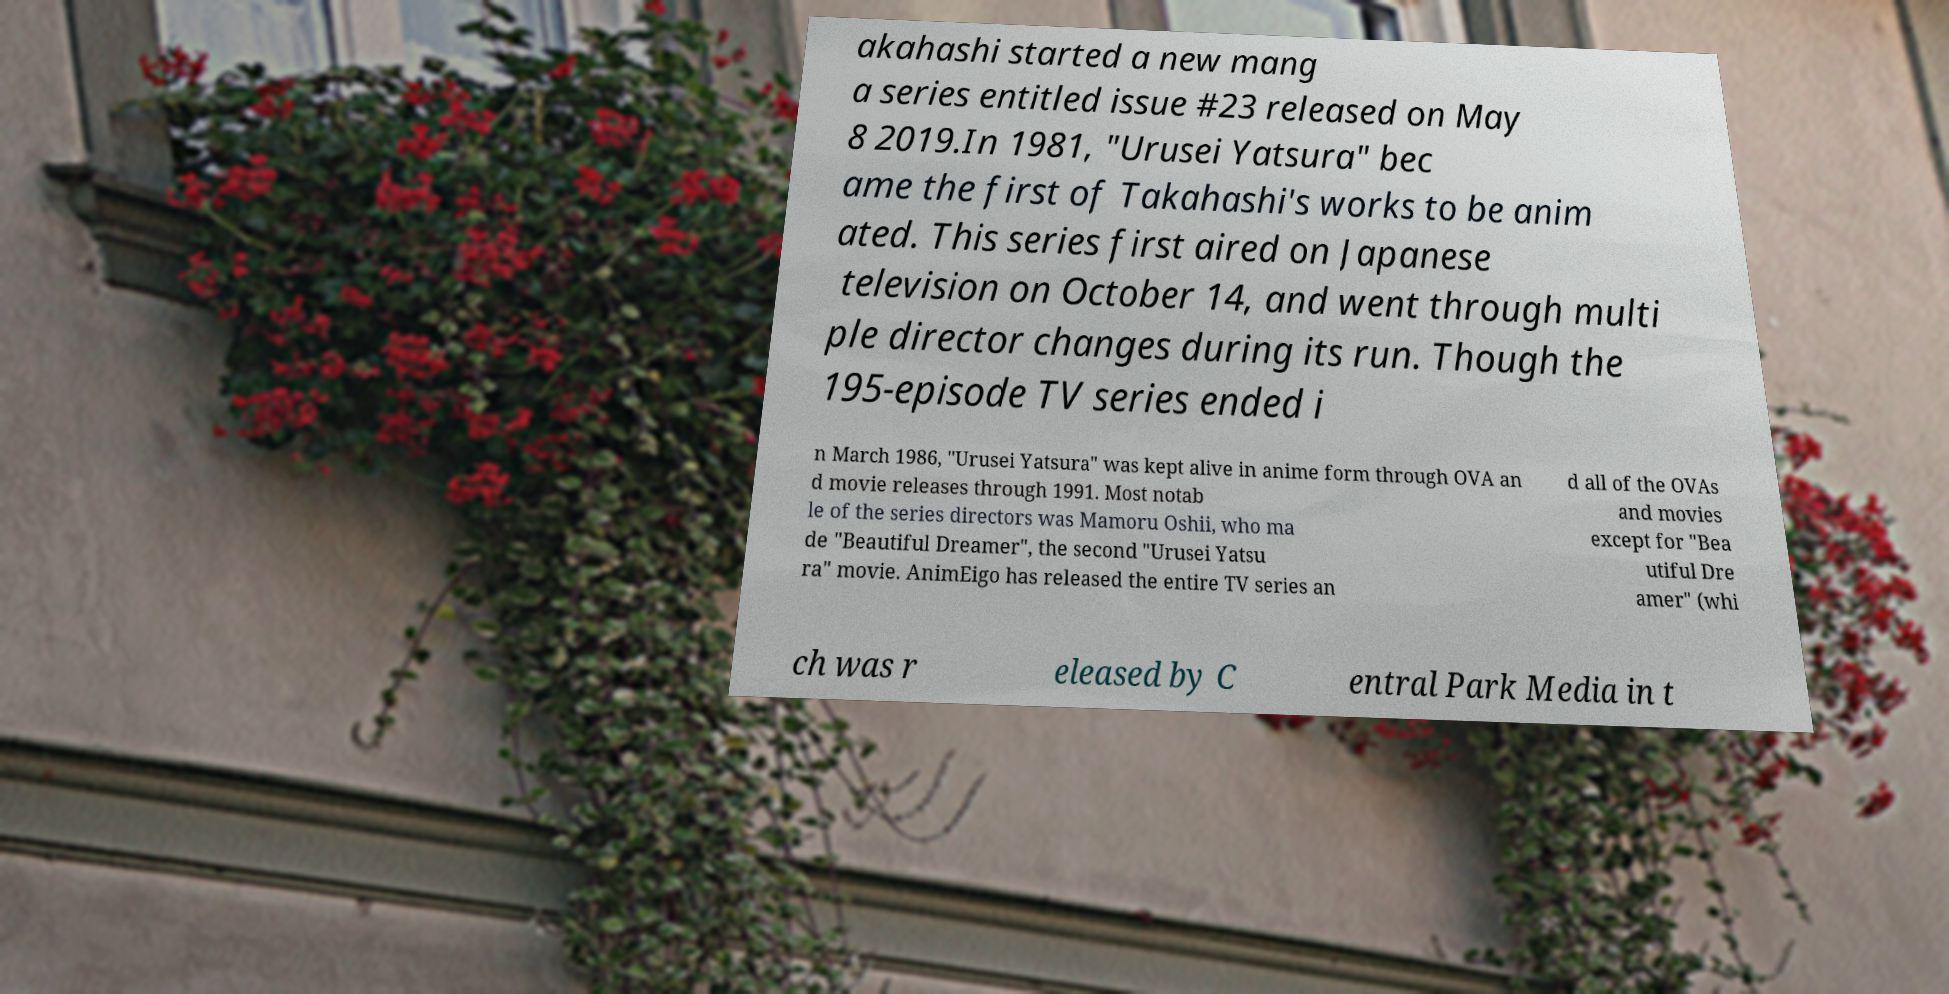For documentation purposes, I need the text within this image transcribed. Could you provide that? akahashi started a new mang a series entitled issue #23 released on May 8 2019.In 1981, "Urusei Yatsura" bec ame the first of Takahashi's works to be anim ated. This series first aired on Japanese television on October 14, and went through multi ple director changes during its run. Though the 195-episode TV series ended i n March 1986, "Urusei Yatsura" was kept alive in anime form through OVA an d movie releases through 1991. Most notab le of the series directors was Mamoru Oshii, who ma de "Beautiful Dreamer", the second "Urusei Yatsu ra" movie. AnimEigo has released the entire TV series an d all of the OVAs and movies except for "Bea utiful Dre amer" (whi ch was r eleased by C entral Park Media in t 